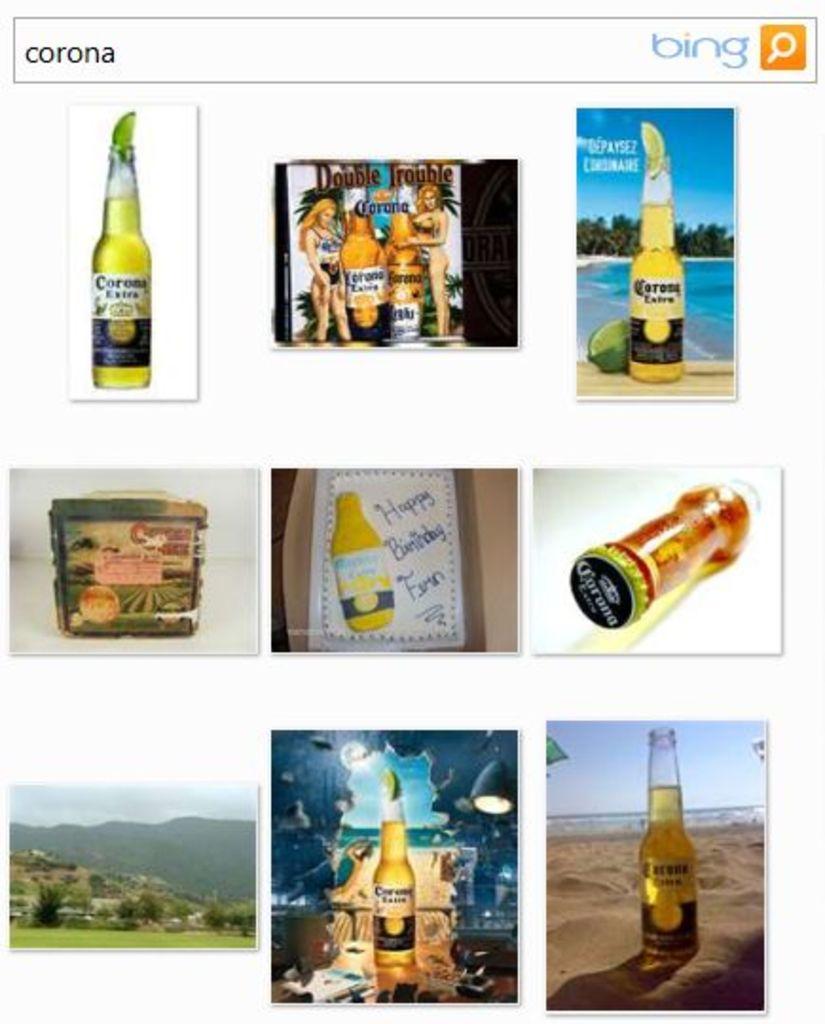What is the search engine?
Offer a terse response. Bing. 